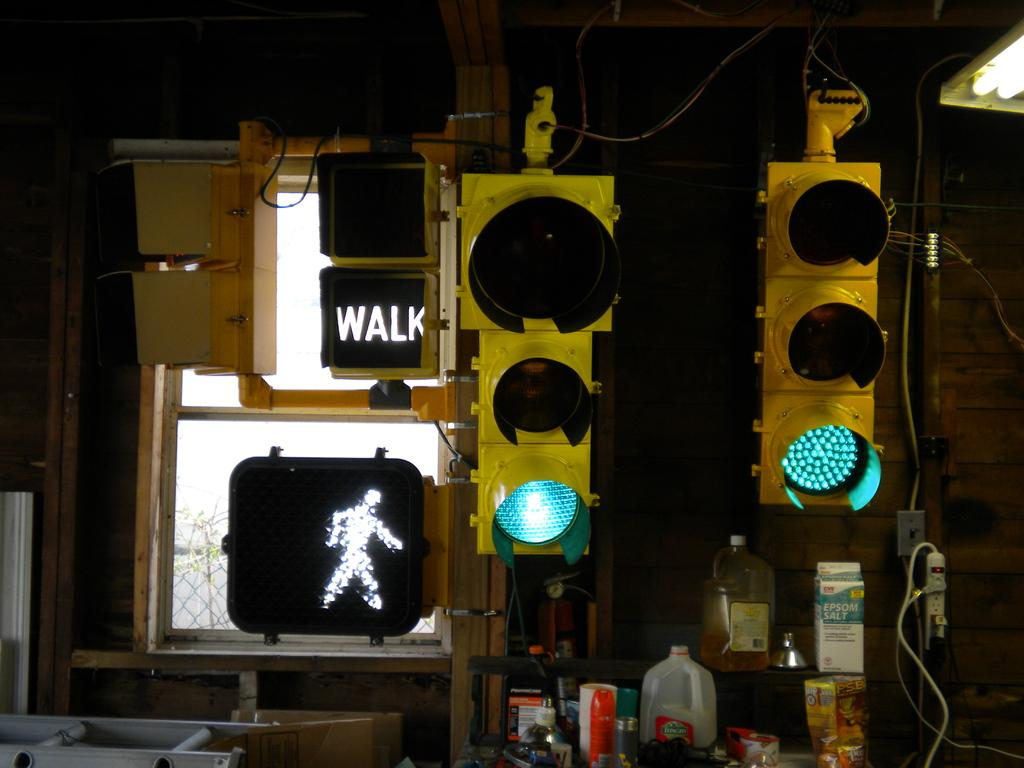Provide a one-sentence caption for the provided image. A traffic light that is green and a sign that says walk. 